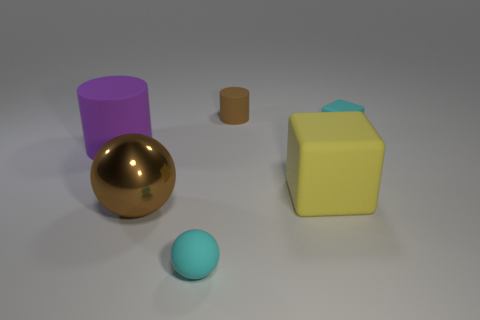Add 1 tiny green spheres. How many objects exist? 7 Subtract all cubes. How many objects are left? 4 Add 6 blue matte cylinders. How many blue matte cylinders exist? 6 Subtract 0 red blocks. How many objects are left? 6 Subtract all large blue cubes. Subtract all tiny brown rubber cylinders. How many objects are left? 5 Add 2 big metal things. How many big metal things are left? 3 